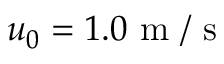Convert formula to latex. <formula><loc_0><loc_0><loc_500><loc_500>{ { u } _ { 0 } } = 1 . 0 m / s</formula> 